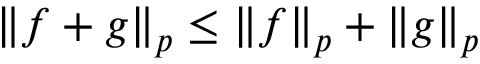<formula> <loc_0><loc_0><loc_500><loc_500>\left \| { f + g } \right \| _ { p } \leq \left \| { f } \right \| _ { p } + \left \| { g } \right \| _ { p }</formula> 